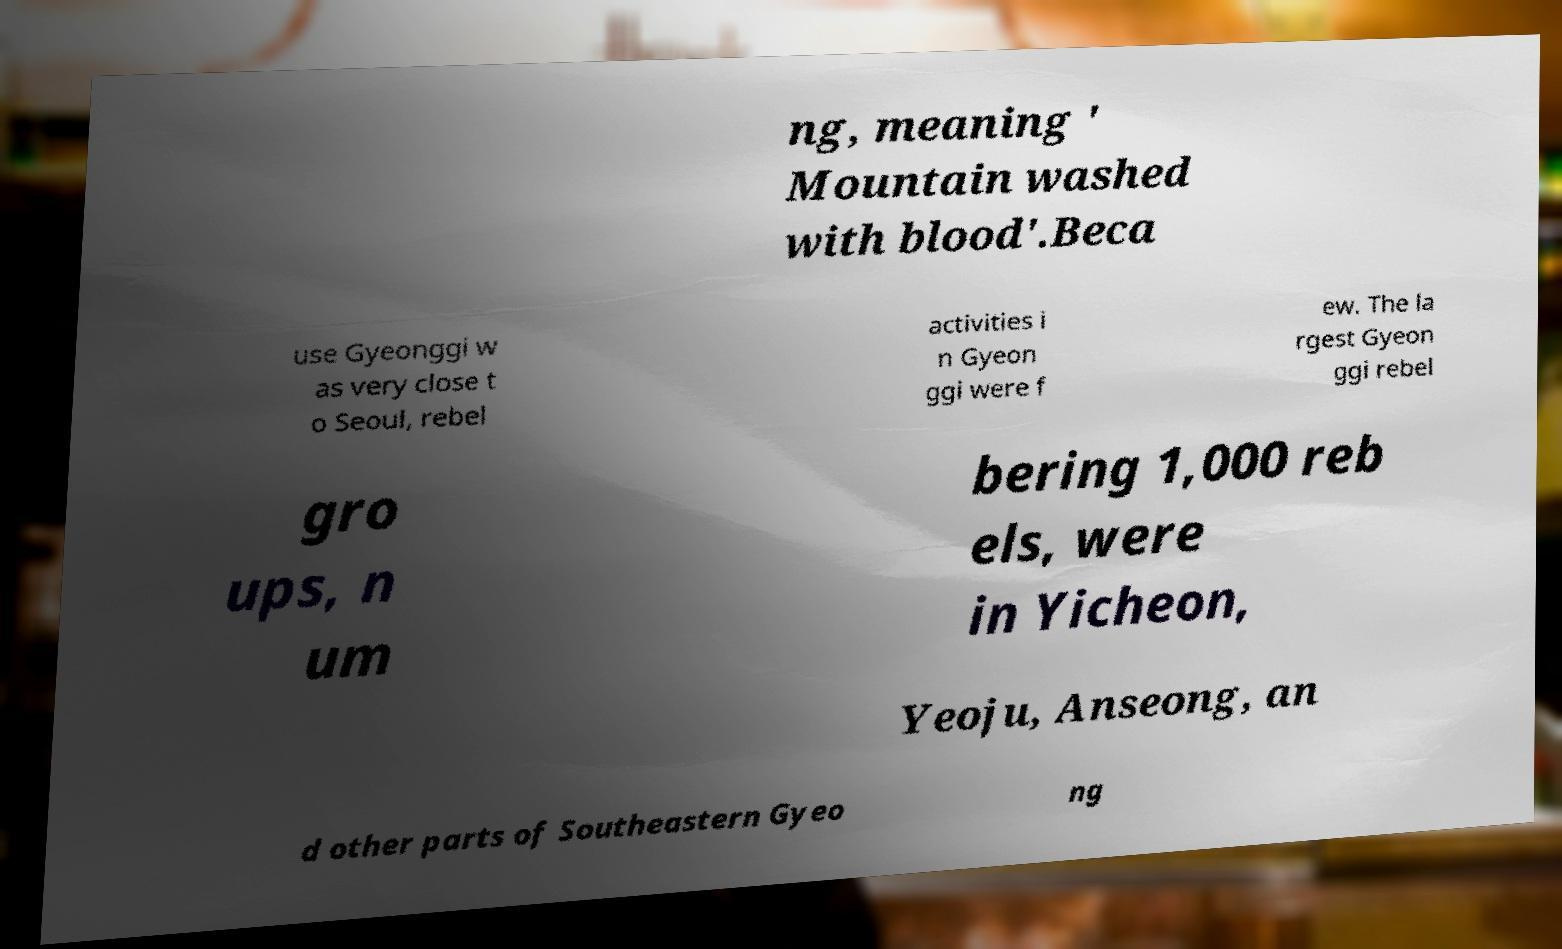Can you read and provide the text displayed in the image?This photo seems to have some interesting text. Can you extract and type it out for me? ng, meaning ' Mountain washed with blood'.Beca use Gyeonggi w as very close t o Seoul, rebel activities i n Gyeon ggi were f ew. The la rgest Gyeon ggi rebel gro ups, n um bering 1,000 reb els, were in Yicheon, Yeoju, Anseong, an d other parts of Southeastern Gyeo ng 